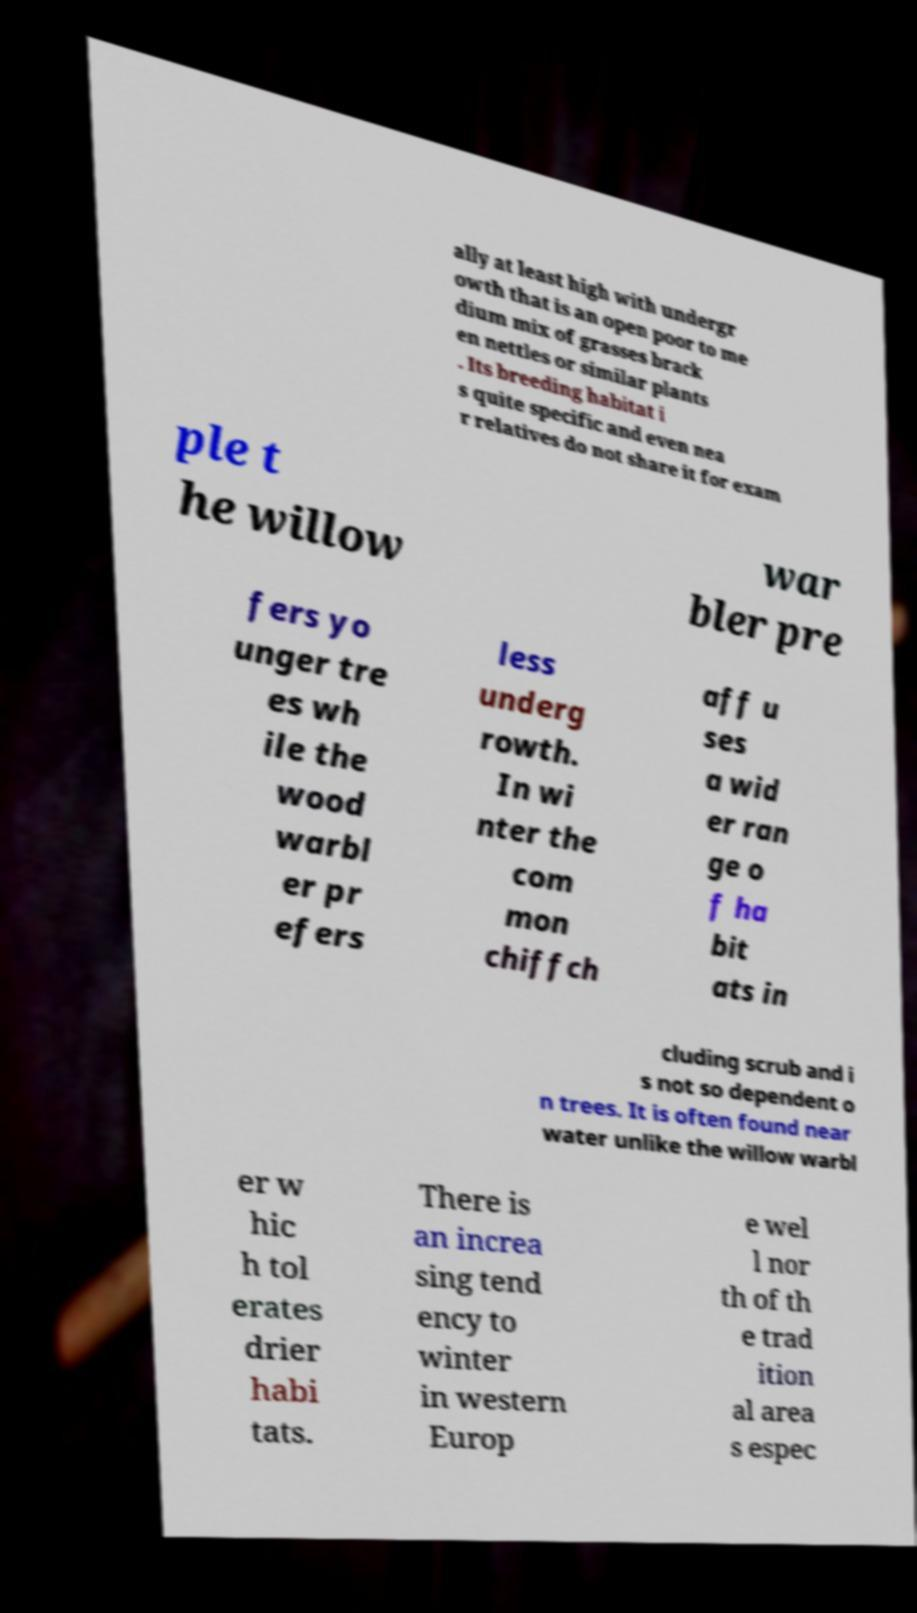Could you assist in decoding the text presented in this image and type it out clearly? ally at least high with undergr owth that is an open poor to me dium mix of grasses brack en nettles or similar plants . Its breeding habitat i s quite specific and even nea r relatives do not share it for exam ple t he willow war bler pre fers yo unger tre es wh ile the wood warbl er pr efers less underg rowth. In wi nter the com mon chiffch aff u ses a wid er ran ge o f ha bit ats in cluding scrub and i s not so dependent o n trees. It is often found near water unlike the willow warbl er w hic h tol erates drier habi tats. There is an increa sing tend ency to winter in western Europ e wel l nor th of th e trad ition al area s espec 